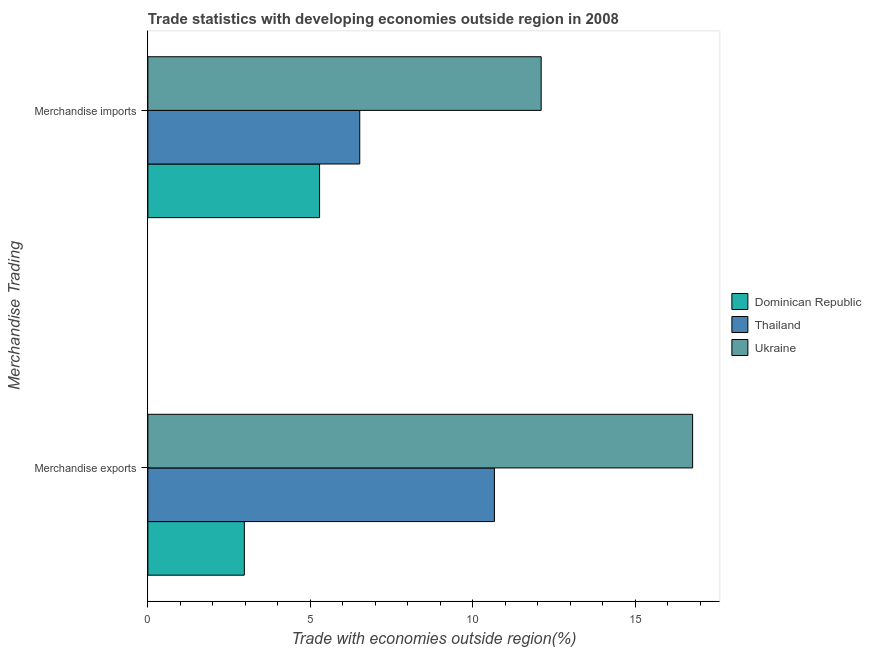How many different coloured bars are there?
Provide a succinct answer. 3. Are the number of bars per tick equal to the number of legend labels?
Your answer should be compact. Yes. Are the number of bars on each tick of the Y-axis equal?
Give a very brief answer. Yes. How many bars are there on the 2nd tick from the top?
Make the answer very short. 3. What is the label of the 1st group of bars from the top?
Keep it short and to the point. Merchandise imports. What is the merchandise exports in Ukraine?
Offer a terse response. 16.77. Across all countries, what is the maximum merchandise exports?
Your response must be concise. 16.77. Across all countries, what is the minimum merchandise exports?
Ensure brevity in your answer.  2.97. In which country was the merchandise exports maximum?
Ensure brevity in your answer.  Ukraine. In which country was the merchandise imports minimum?
Your response must be concise. Dominican Republic. What is the total merchandise exports in the graph?
Offer a terse response. 30.41. What is the difference between the merchandise imports in Ukraine and that in Dominican Republic?
Your response must be concise. 6.82. What is the difference between the merchandise imports in Dominican Republic and the merchandise exports in Ukraine?
Provide a short and direct response. -11.48. What is the average merchandise imports per country?
Ensure brevity in your answer.  7.97. What is the difference between the merchandise imports and merchandise exports in Dominican Republic?
Offer a terse response. 2.32. In how many countries, is the merchandise exports greater than 8 %?
Offer a terse response. 2. What is the ratio of the merchandise exports in Thailand to that in Ukraine?
Your answer should be compact. 0.64. Is the merchandise exports in Thailand less than that in Dominican Republic?
Give a very brief answer. No. What does the 1st bar from the top in Merchandise imports represents?
Provide a short and direct response. Ukraine. What does the 1st bar from the bottom in Merchandise imports represents?
Provide a succinct answer. Dominican Republic. Are all the bars in the graph horizontal?
Provide a short and direct response. Yes. What is the difference between two consecutive major ticks on the X-axis?
Give a very brief answer. 5. Are the values on the major ticks of X-axis written in scientific E-notation?
Ensure brevity in your answer.  No. Does the graph contain any zero values?
Your answer should be compact. No. Does the graph contain grids?
Offer a very short reply. No. Where does the legend appear in the graph?
Provide a succinct answer. Center right. What is the title of the graph?
Offer a very short reply. Trade statistics with developing economies outside region in 2008. What is the label or title of the X-axis?
Make the answer very short. Trade with economies outside region(%). What is the label or title of the Y-axis?
Provide a short and direct response. Merchandise Trading. What is the Trade with economies outside region(%) in Dominican Republic in Merchandise exports?
Your answer should be very brief. 2.97. What is the Trade with economies outside region(%) of Thailand in Merchandise exports?
Keep it short and to the point. 10.67. What is the Trade with economies outside region(%) of Ukraine in Merchandise exports?
Your answer should be compact. 16.77. What is the Trade with economies outside region(%) in Dominican Republic in Merchandise imports?
Your answer should be compact. 5.29. What is the Trade with economies outside region(%) of Thailand in Merchandise imports?
Your response must be concise. 6.52. What is the Trade with economies outside region(%) in Ukraine in Merchandise imports?
Offer a very short reply. 12.11. Across all Merchandise Trading, what is the maximum Trade with economies outside region(%) of Dominican Republic?
Provide a short and direct response. 5.29. Across all Merchandise Trading, what is the maximum Trade with economies outside region(%) of Thailand?
Give a very brief answer. 10.67. Across all Merchandise Trading, what is the maximum Trade with economies outside region(%) in Ukraine?
Your response must be concise. 16.77. Across all Merchandise Trading, what is the minimum Trade with economies outside region(%) of Dominican Republic?
Provide a short and direct response. 2.97. Across all Merchandise Trading, what is the minimum Trade with economies outside region(%) of Thailand?
Provide a succinct answer. 6.52. Across all Merchandise Trading, what is the minimum Trade with economies outside region(%) in Ukraine?
Give a very brief answer. 12.11. What is the total Trade with economies outside region(%) in Dominican Republic in the graph?
Make the answer very short. 8.26. What is the total Trade with economies outside region(%) of Thailand in the graph?
Provide a succinct answer. 17.19. What is the total Trade with economies outside region(%) in Ukraine in the graph?
Provide a short and direct response. 28.88. What is the difference between the Trade with economies outside region(%) of Dominican Republic in Merchandise exports and that in Merchandise imports?
Give a very brief answer. -2.32. What is the difference between the Trade with economies outside region(%) in Thailand in Merchandise exports and that in Merchandise imports?
Your answer should be very brief. 4.14. What is the difference between the Trade with economies outside region(%) in Ukraine in Merchandise exports and that in Merchandise imports?
Offer a very short reply. 4.66. What is the difference between the Trade with economies outside region(%) in Dominican Republic in Merchandise exports and the Trade with economies outside region(%) in Thailand in Merchandise imports?
Your answer should be very brief. -3.55. What is the difference between the Trade with economies outside region(%) in Dominican Republic in Merchandise exports and the Trade with economies outside region(%) in Ukraine in Merchandise imports?
Provide a succinct answer. -9.14. What is the difference between the Trade with economies outside region(%) of Thailand in Merchandise exports and the Trade with economies outside region(%) of Ukraine in Merchandise imports?
Provide a succinct answer. -1.44. What is the average Trade with economies outside region(%) in Dominican Republic per Merchandise Trading?
Your answer should be very brief. 4.13. What is the average Trade with economies outside region(%) of Thailand per Merchandise Trading?
Your answer should be very brief. 8.59. What is the average Trade with economies outside region(%) in Ukraine per Merchandise Trading?
Your response must be concise. 14.44. What is the difference between the Trade with economies outside region(%) of Dominican Republic and Trade with economies outside region(%) of Thailand in Merchandise exports?
Your response must be concise. -7.7. What is the difference between the Trade with economies outside region(%) of Dominican Republic and Trade with economies outside region(%) of Ukraine in Merchandise exports?
Your answer should be very brief. -13.8. What is the difference between the Trade with economies outside region(%) in Thailand and Trade with economies outside region(%) in Ukraine in Merchandise exports?
Offer a terse response. -6.1. What is the difference between the Trade with economies outside region(%) in Dominican Republic and Trade with economies outside region(%) in Thailand in Merchandise imports?
Your answer should be compact. -1.24. What is the difference between the Trade with economies outside region(%) in Dominican Republic and Trade with economies outside region(%) in Ukraine in Merchandise imports?
Your answer should be compact. -6.82. What is the difference between the Trade with economies outside region(%) in Thailand and Trade with economies outside region(%) in Ukraine in Merchandise imports?
Provide a short and direct response. -5.58. What is the ratio of the Trade with economies outside region(%) in Dominican Republic in Merchandise exports to that in Merchandise imports?
Ensure brevity in your answer.  0.56. What is the ratio of the Trade with economies outside region(%) of Thailand in Merchandise exports to that in Merchandise imports?
Provide a succinct answer. 1.64. What is the ratio of the Trade with economies outside region(%) in Ukraine in Merchandise exports to that in Merchandise imports?
Offer a very short reply. 1.39. What is the difference between the highest and the second highest Trade with economies outside region(%) of Dominican Republic?
Make the answer very short. 2.32. What is the difference between the highest and the second highest Trade with economies outside region(%) of Thailand?
Provide a short and direct response. 4.14. What is the difference between the highest and the second highest Trade with economies outside region(%) of Ukraine?
Provide a succinct answer. 4.66. What is the difference between the highest and the lowest Trade with economies outside region(%) of Dominican Republic?
Provide a succinct answer. 2.32. What is the difference between the highest and the lowest Trade with economies outside region(%) in Thailand?
Give a very brief answer. 4.14. What is the difference between the highest and the lowest Trade with economies outside region(%) of Ukraine?
Provide a short and direct response. 4.66. 